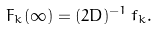<formula> <loc_0><loc_0><loc_500><loc_500>F _ { k } ( \infty ) = ( 2 D ) ^ { - 1 } \, f _ { k } .</formula> 